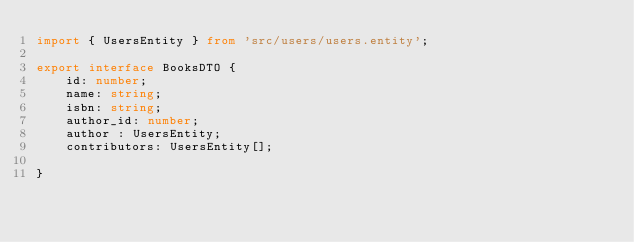<code> <loc_0><loc_0><loc_500><loc_500><_TypeScript_>import { UsersEntity } from 'src/users/users.entity';

export interface BooksDTO {
    id: number;
    name: string;
    isbn: string;
    author_id: number;
    author : UsersEntity;
    contributors: UsersEntity[];
  
}</code> 